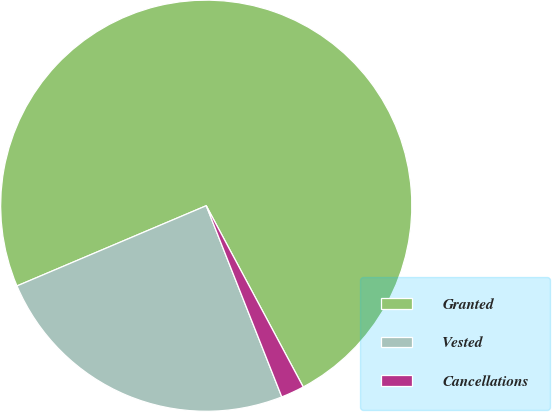Convert chart. <chart><loc_0><loc_0><loc_500><loc_500><pie_chart><fcel>Granted<fcel>Vested<fcel>Cancellations<nl><fcel>73.56%<fcel>24.61%<fcel>1.83%<nl></chart> 